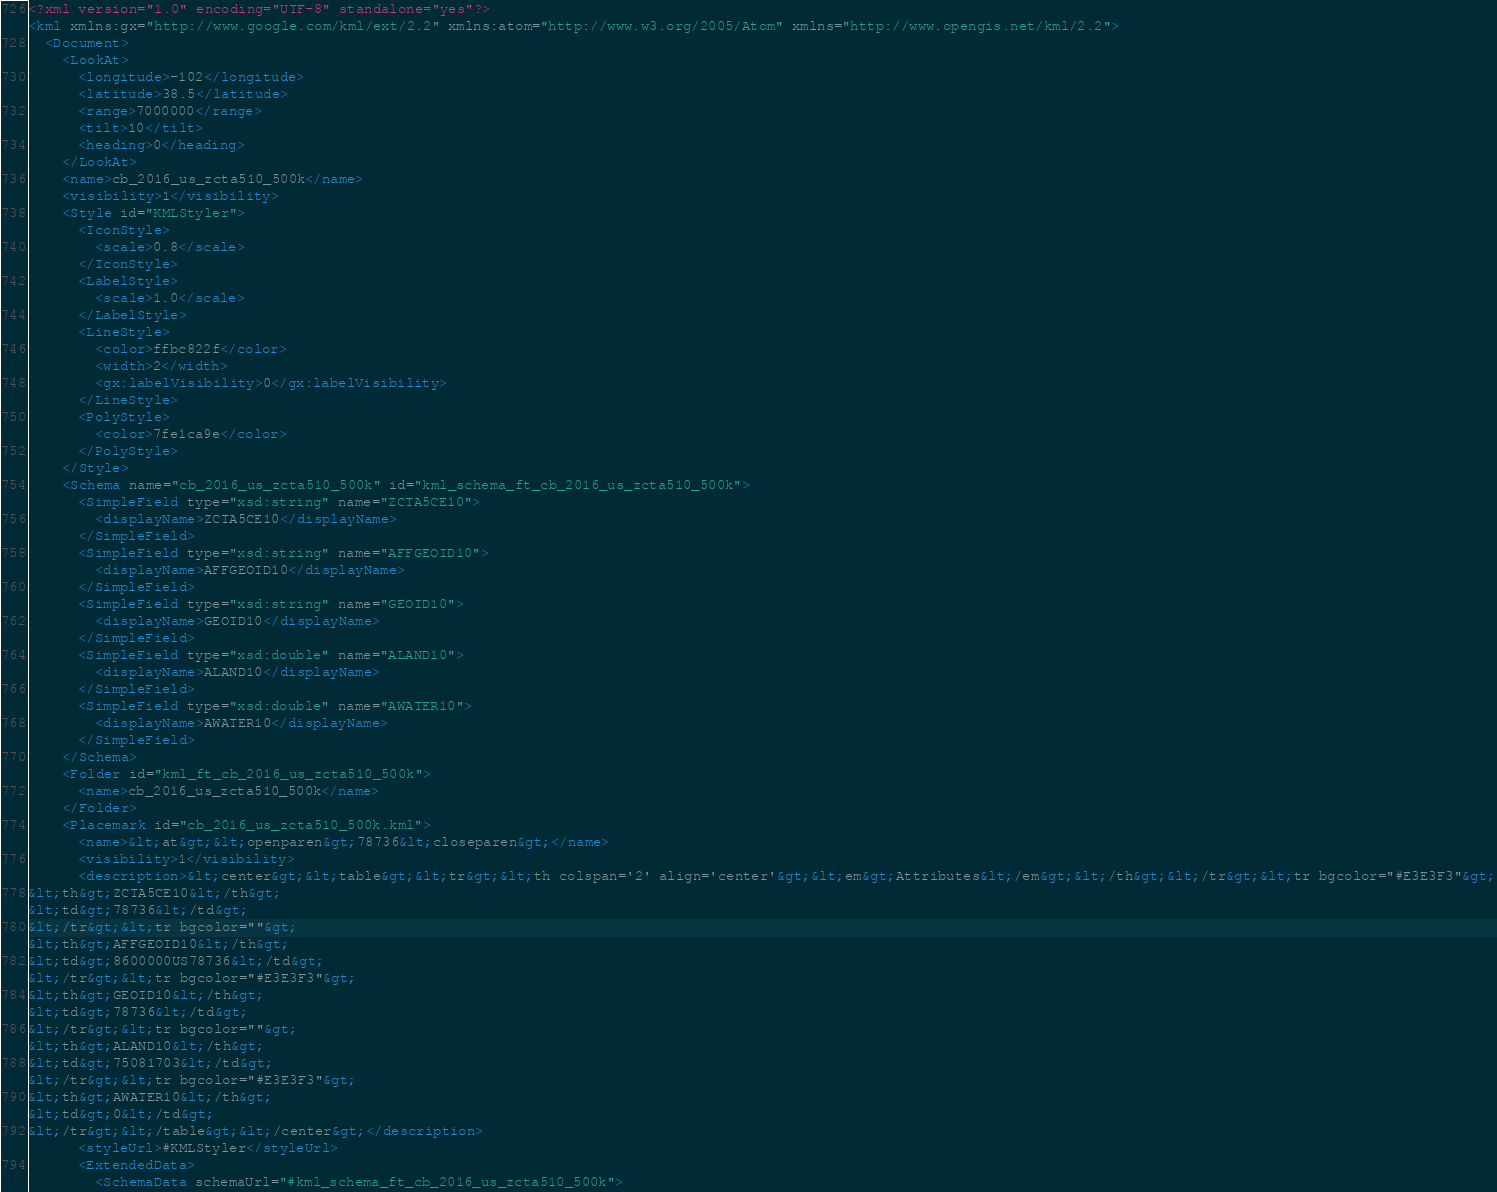<code> <loc_0><loc_0><loc_500><loc_500><_XML_><?xml version="1.0" encoding="UTF-8" standalone="yes"?>
<kml xmlns:gx="http://www.google.com/kml/ext/2.2" xmlns:atom="http://www.w3.org/2005/Atom" xmlns="http://www.opengis.net/kml/2.2">
  <Document>
    <LookAt>
      <longitude>-102</longitude>
      <latitude>38.5</latitude>
      <range>7000000</range>
      <tilt>10</tilt>
      <heading>0</heading>
    </LookAt>
    <name>cb_2016_us_zcta510_500k</name>
    <visibility>1</visibility>
    <Style id="KMLStyler">
      <IconStyle>
        <scale>0.8</scale>
      </IconStyle>
      <LabelStyle>
        <scale>1.0</scale>
      </LabelStyle>
      <LineStyle>
        <color>ffbc822f</color>
        <width>2</width>
        <gx:labelVisibility>0</gx:labelVisibility>
      </LineStyle>
      <PolyStyle>
        <color>7fe1ca9e</color>
      </PolyStyle>
    </Style>
    <Schema name="cb_2016_us_zcta510_500k" id="kml_schema_ft_cb_2016_us_zcta510_500k">
      <SimpleField type="xsd:string" name="ZCTA5CE10">
        <displayName>ZCTA5CE10</displayName>
      </SimpleField>
      <SimpleField type="xsd:string" name="AFFGEOID10">
        <displayName>AFFGEOID10</displayName>
      </SimpleField>
      <SimpleField type="xsd:string" name="GEOID10">
        <displayName>GEOID10</displayName>
      </SimpleField>
      <SimpleField type="xsd:double" name="ALAND10">
        <displayName>ALAND10</displayName>
      </SimpleField>
      <SimpleField type="xsd:double" name="AWATER10">
        <displayName>AWATER10</displayName>
      </SimpleField>
    </Schema>
    <Folder id="kml_ft_cb_2016_us_zcta510_500k">
      <name>cb_2016_us_zcta510_500k</name>
    </Folder>
    <Placemark id="cb_2016_us_zcta510_500k.kml">
      <name>&lt;at&gt;&lt;openparen&gt;78736&lt;closeparen&gt;</name>
      <visibility>1</visibility>
      <description>&lt;center&gt;&lt;table&gt;&lt;tr&gt;&lt;th colspan='2' align='center'&gt;&lt;em&gt;Attributes&lt;/em&gt;&lt;/th&gt;&lt;/tr&gt;&lt;tr bgcolor="#E3E3F3"&gt;
&lt;th&gt;ZCTA5CE10&lt;/th&gt;
&lt;td&gt;78736&lt;/td&gt;
&lt;/tr&gt;&lt;tr bgcolor=""&gt;
&lt;th&gt;AFFGEOID10&lt;/th&gt;
&lt;td&gt;8600000US78736&lt;/td&gt;
&lt;/tr&gt;&lt;tr bgcolor="#E3E3F3"&gt;
&lt;th&gt;GEOID10&lt;/th&gt;
&lt;td&gt;78736&lt;/td&gt;
&lt;/tr&gt;&lt;tr bgcolor=""&gt;
&lt;th&gt;ALAND10&lt;/th&gt;
&lt;td&gt;75081703&lt;/td&gt;
&lt;/tr&gt;&lt;tr bgcolor="#E3E3F3"&gt;
&lt;th&gt;AWATER10&lt;/th&gt;
&lt;td&gt;0&lt;/td&gt;
&lt;/tr&gt;&lt;/table&gt;&lt;/center&gt;</description>
      <styleUrl>#KMLStyler</styleUrl>
      <ExtendedData>
        <SchemaData schemaUrl="#kml_schema_ft_cb_2016_us_zcta510_500k"></code> 